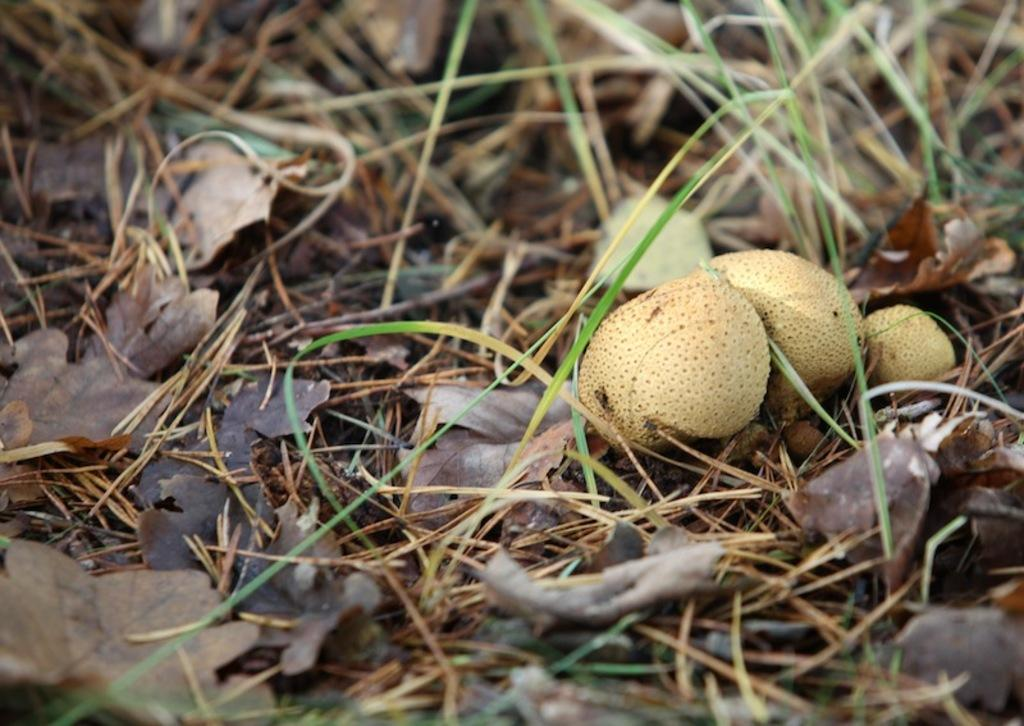What type of vegetation can be seen in the image? There is grass in the image. What else can be found on the ground in the image? There are dry leaves in the image. Can you describe any other objects or features in the image? There are unspecified objects in the image. What type of punishment is being administered to the giraffe in the image? There is no giraffe present in the image, and therefore no punishment is being administered. How long does the minute-long event depicted in the image last? There is no event or time duration mentioned in the image, so it is impossible to determine the length of any event. 